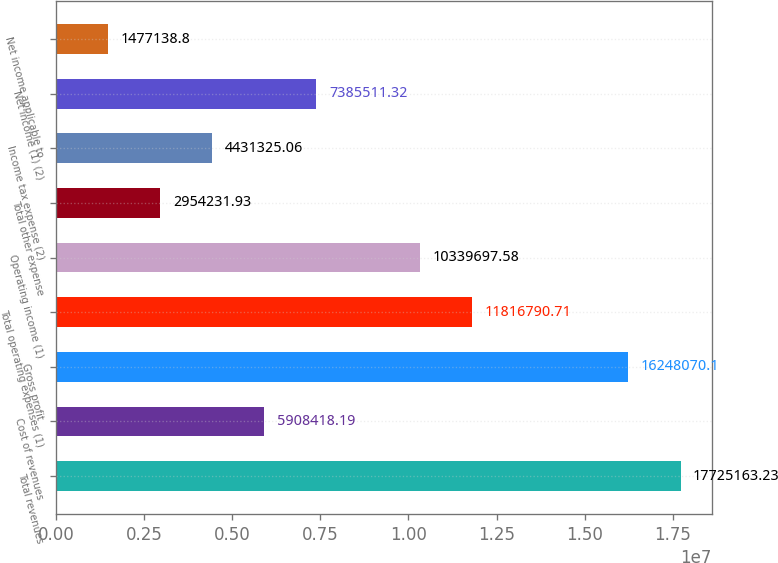<chart> <loc_0><loc_0><loc_500><loc_500><bar_chart><fcel>Total revenues<fcel>Cost of revenues<fcel>Gross profit<fcel>Total operating expenses (1)<fcel>Operating income (1)<fcel>Total other expense<fcel>Income tax expense (2)<fcel>Net income (1) (2)<fcel>Net income applicable to<nl><fcel>1.77252e+07<fcel>5.90842e+06<fcel>1.62481e+07<fcel>1.18168e+07<fcel>1.03397e+07<fcel>2.95423e+06<fcel>4.43133e+06<fcel>7.38551e+06<fcel>1.47714e+06<nl></chart> 